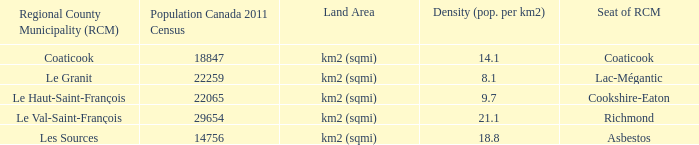What is the location of the rcm's headquarters in the county with a population density of 9.7? Cookshire-Eaton. 